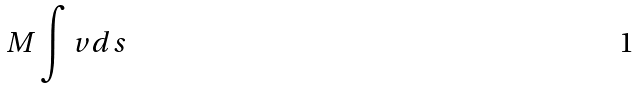<formula> <loc_0><loc_0><loc_500><loc_500>M \int v d s</formula> 